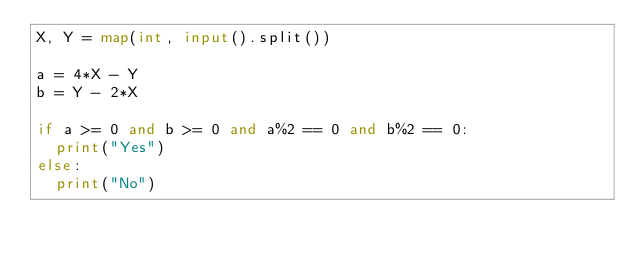Convert code to text. <code><loc_0><loc_0><loc_500><loc_500><_Python_>X, Y = map(int, input().split())

a = 4*X - Y
b = Y - 2*X

if a >= 0 and b >= 0 and a%2 == 0 and b%2 == 0:
  print("Yes")
else:
  print("No")</code> 